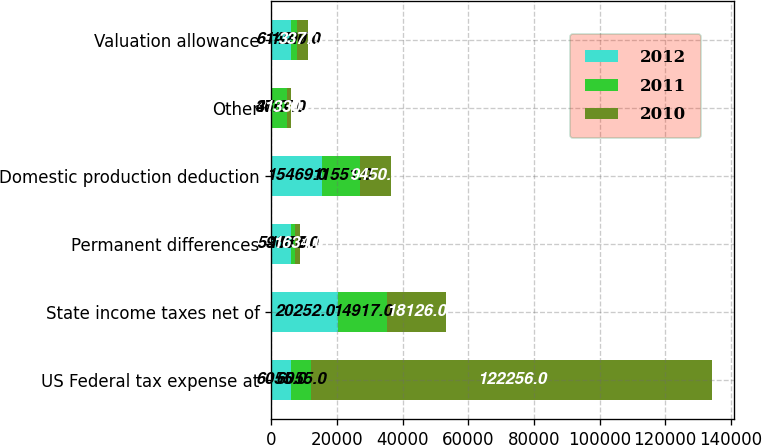Convert chart. <chart><loc_0><loc_0><loc_500><loc_500><stacked_bar_chart><ecel><fcel>US Federal tax expense at<fcel>State income taxes net of<fcel>Permanent differences<fcel>Domestic production deduction<fcel>Other<fcel>Valuation allowance<nl><fcel>2012<fcel>6055<fcel>20252<fcel>5968<fcel>15469<fcel>37<fcel>6142<nl><fcel>2011<fcel>6055<fcel>14917<fcel>1176<fcel>11551<fcel>4667<fcel>1797<nl><fcel>2010<fcel>122256<fcel>18126<fcel>1634<fcel>9450<fcel>1330<fcel>3377<nl></chart> 